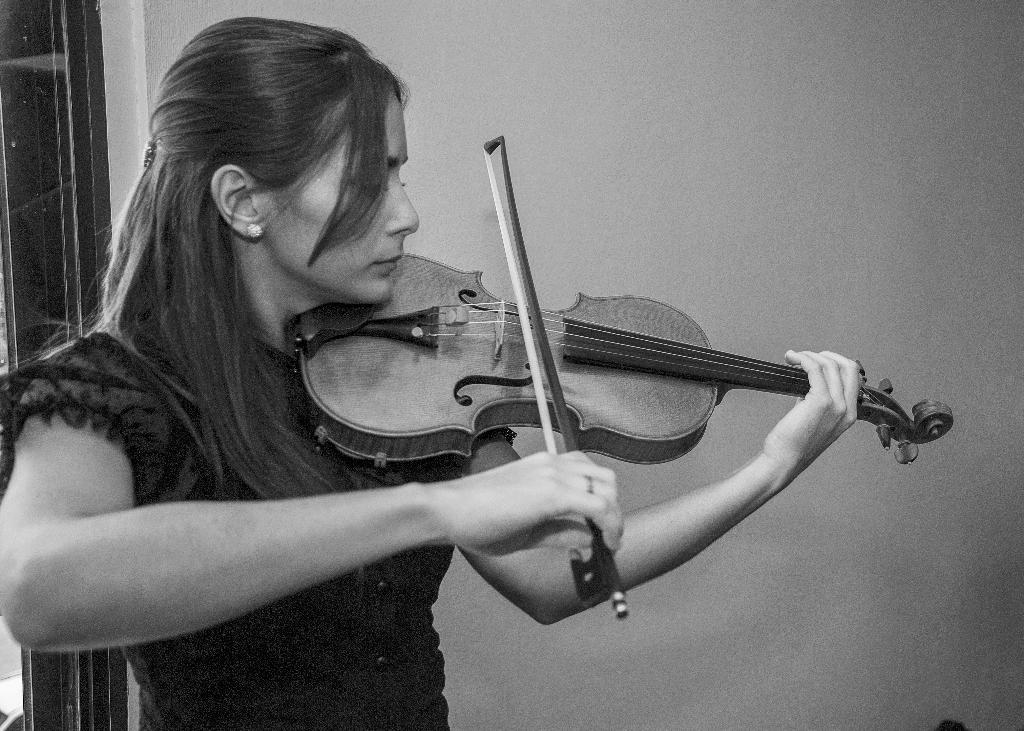Who is present in the image? There is a lady in the image. What is the lady holding in the image? The lady is holding a musical instrument. What type of polish is the lady applying to the mice in the image? There are no mice or polish present in the image; it features a lady holding a musical instrument. What type of turkey is visible in the image? There is no turkey present in the image. 